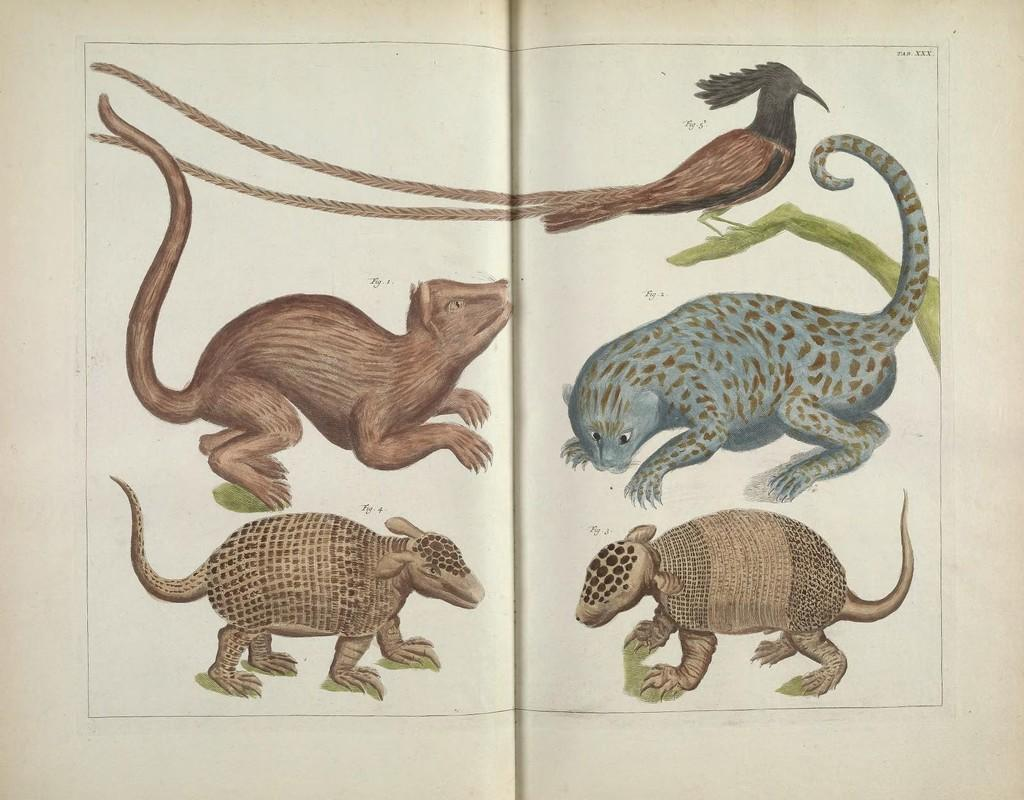What is the main object in the image? There is a book in the image. What type of content does the book contain? The book contains text, numbers, and depictions of animals. Can you describe a specific animal depicted in the book? Yes, there is a depiction of a bird in the book. How many houses are visible in the book? There are no houses visible in the book; it contains text, numbers, and depictions of animals. What type of calculator is used to solve the equations in the book? There is no calculator mentioned or depicted in the book; it contains text, numbers, and depictions of animals. 